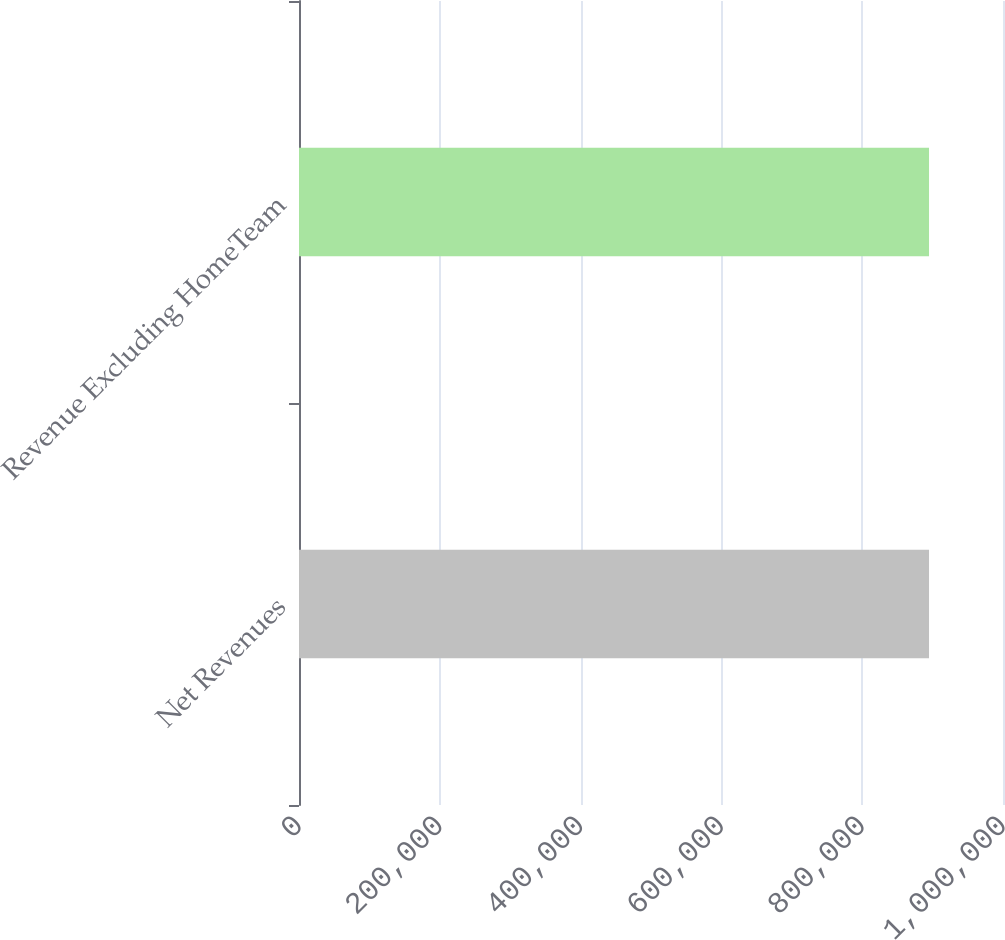<chart> <loc_0><loc_0><loc_500><loc_500><bar_chart><fcel>Net Revenues<fcel>Revenue Excluding HomeTeam<nl><fcel>894920<fcel>894920<nl></chart> 